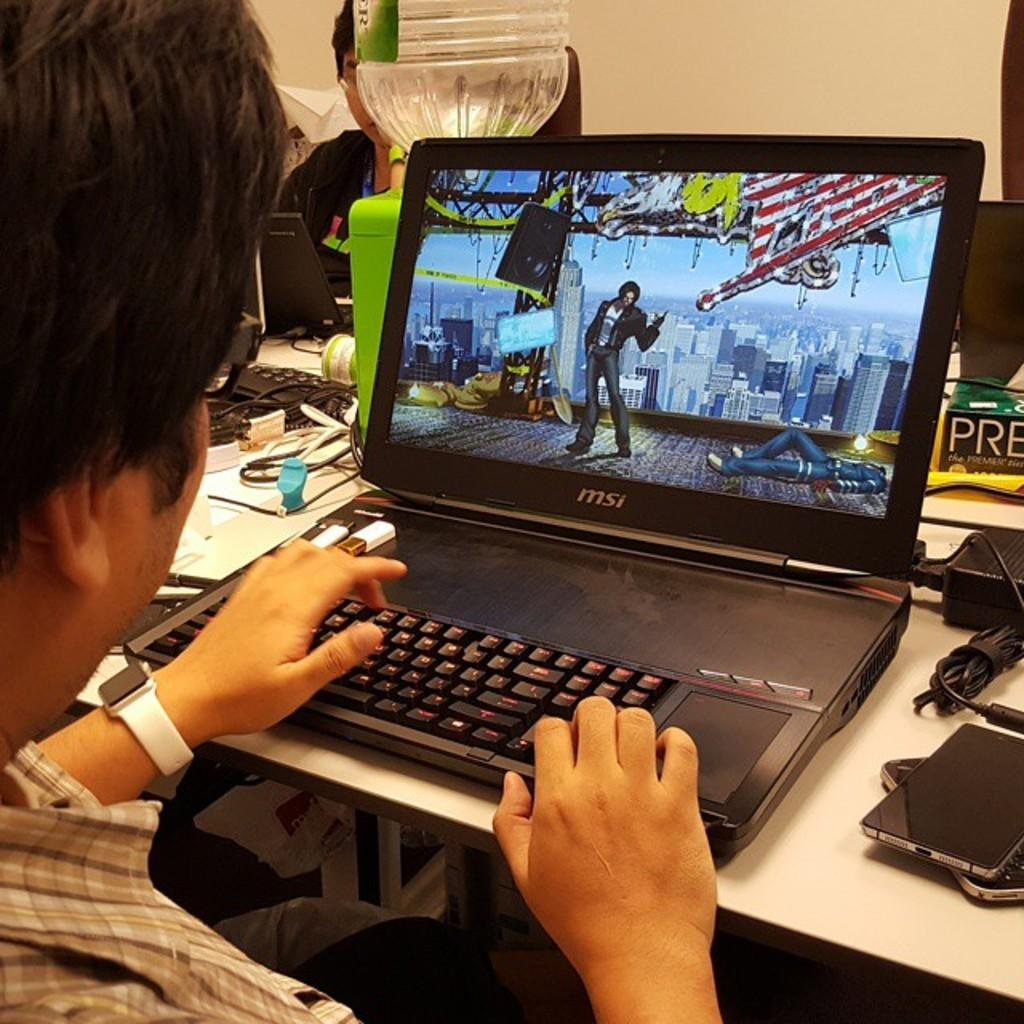<image>
Present a compact description of the photo's key features. Someone is working on an MSi brand laptop. 